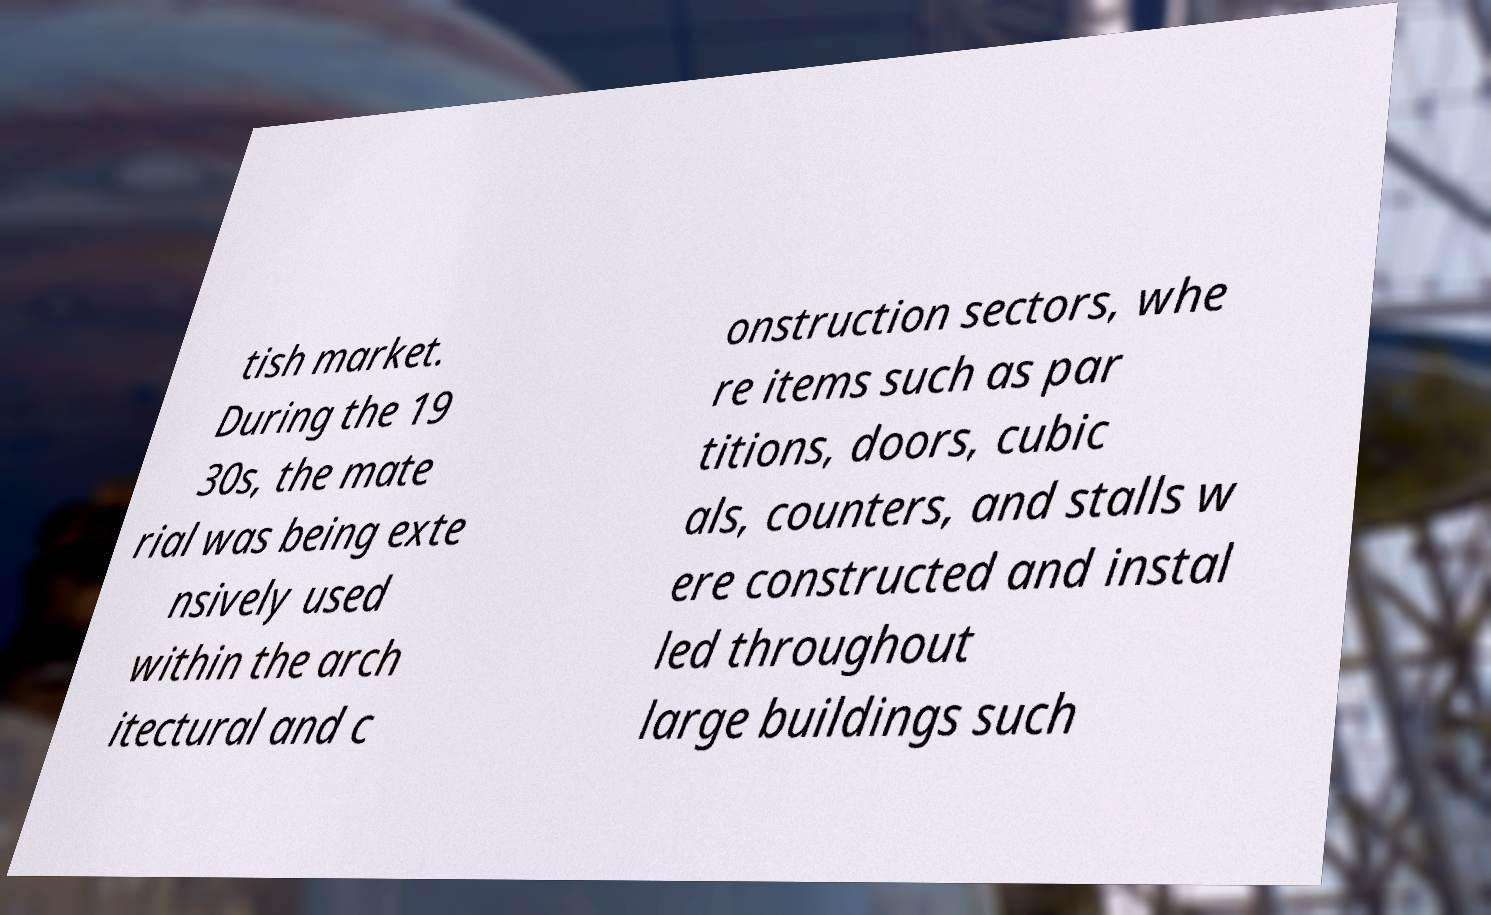Could you extract and type out the text from this image? tish market. During the 19 30s, the mate rial was being exte nsively used within the arch itectural and c onstruction sectors, whe re items such as par titions, doors, cubic als, counters, and stalls w ere constructed and instal led throughout large buildings such 